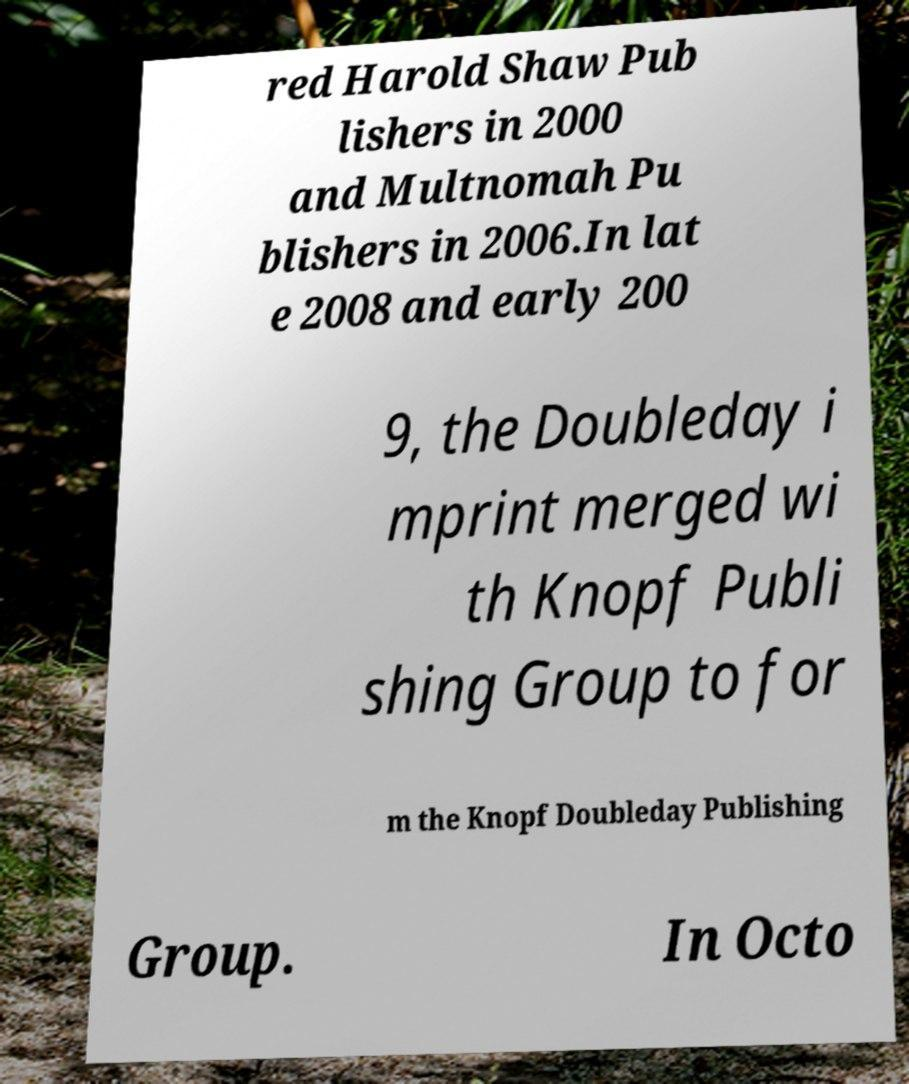Can you accurately transcribe the text from the provided image for me? red Harold Shaw Pub lishers in 2000 and Multnomah Pu blishers in 2006.In lat e 2008 and early 200 9, the Doubleday i mprint merged wi th Knopf Publi shing Group to for m the Knopf Doubleday Publishing Group. In Octo 